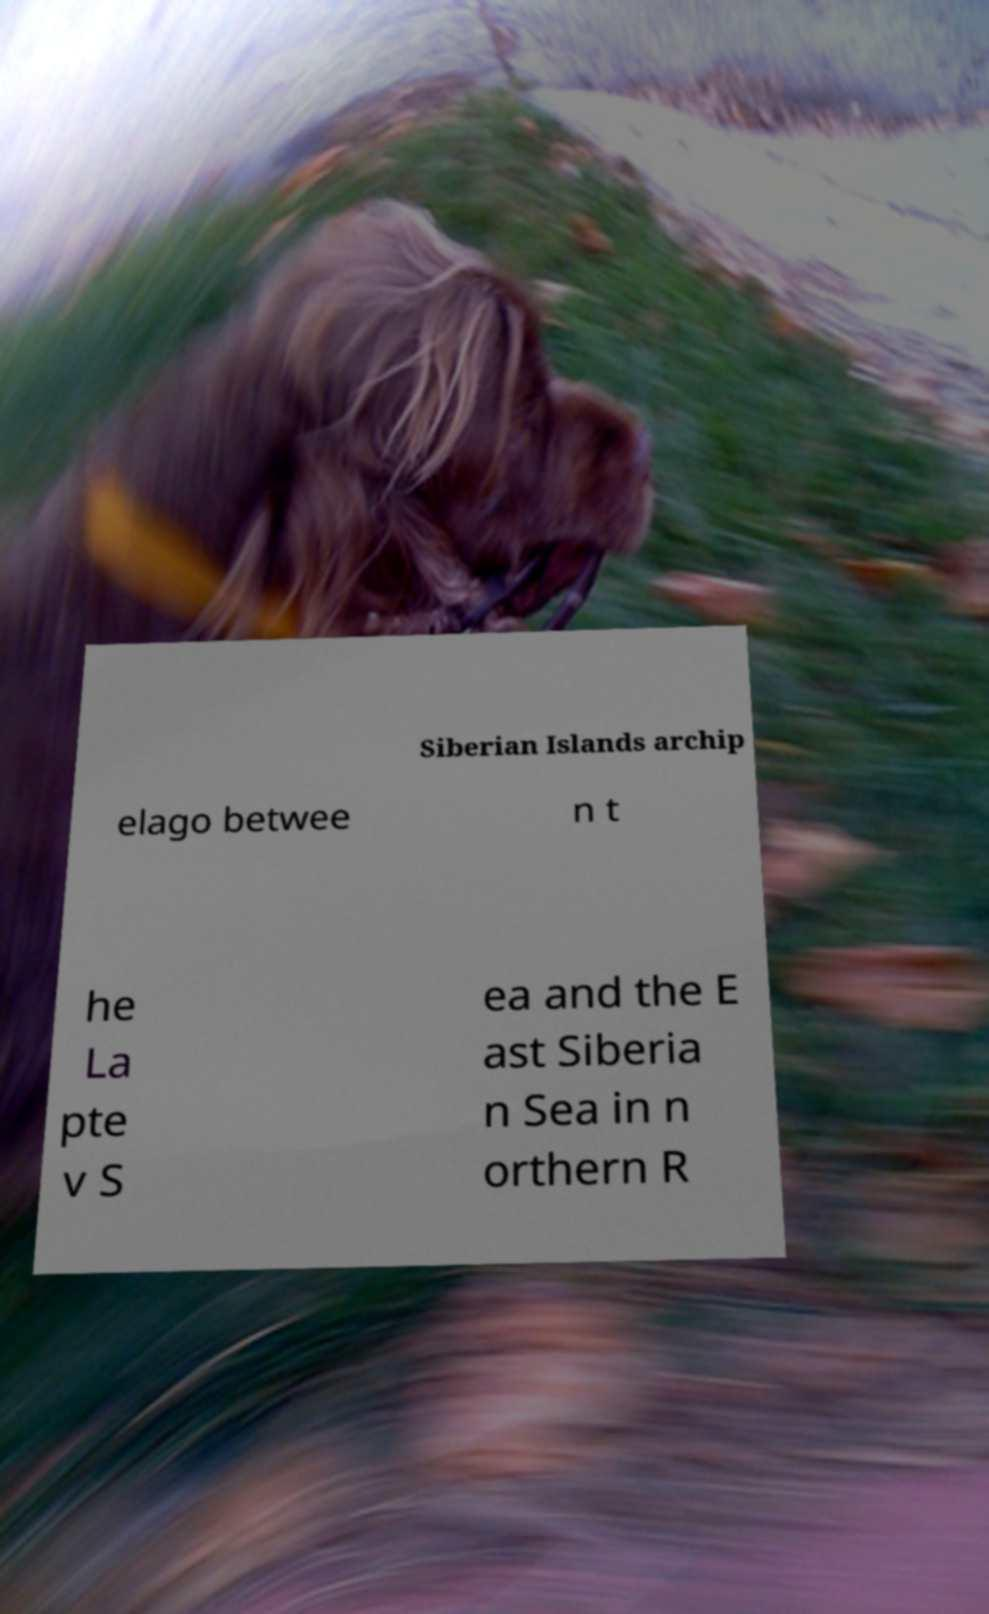Can you read and provide the text displayed in the image?This photo seems to have some interesting text. Can you extract and type it out for me? Siberian Islands archip elago betwee n t he La pte v S ea and the E ast Siberia n Sea in n orthern R 